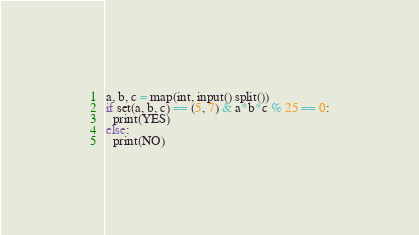Convert code to text. <code><loc_0><loc_0><loc_500><loc_500><_Python_>a, b, c = map(int, input().split())
if set(a, b, c) == (5, 7) & a*b*c % 25 == 0:
  print(YES)
else:
  print(NO)</code> 